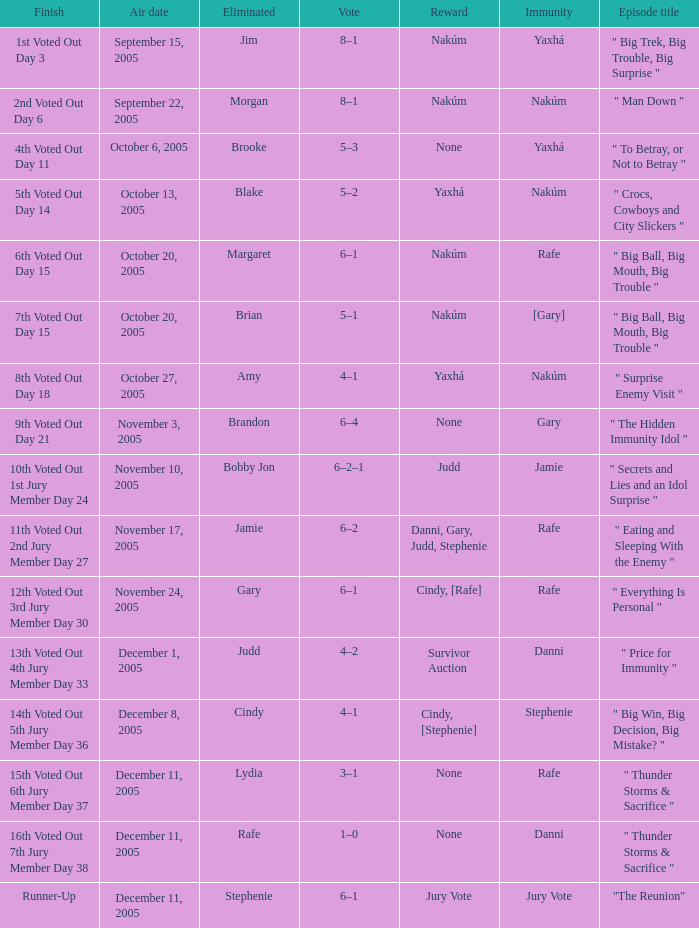How many air dates were there when Morgan was eliminated? 1.0. 